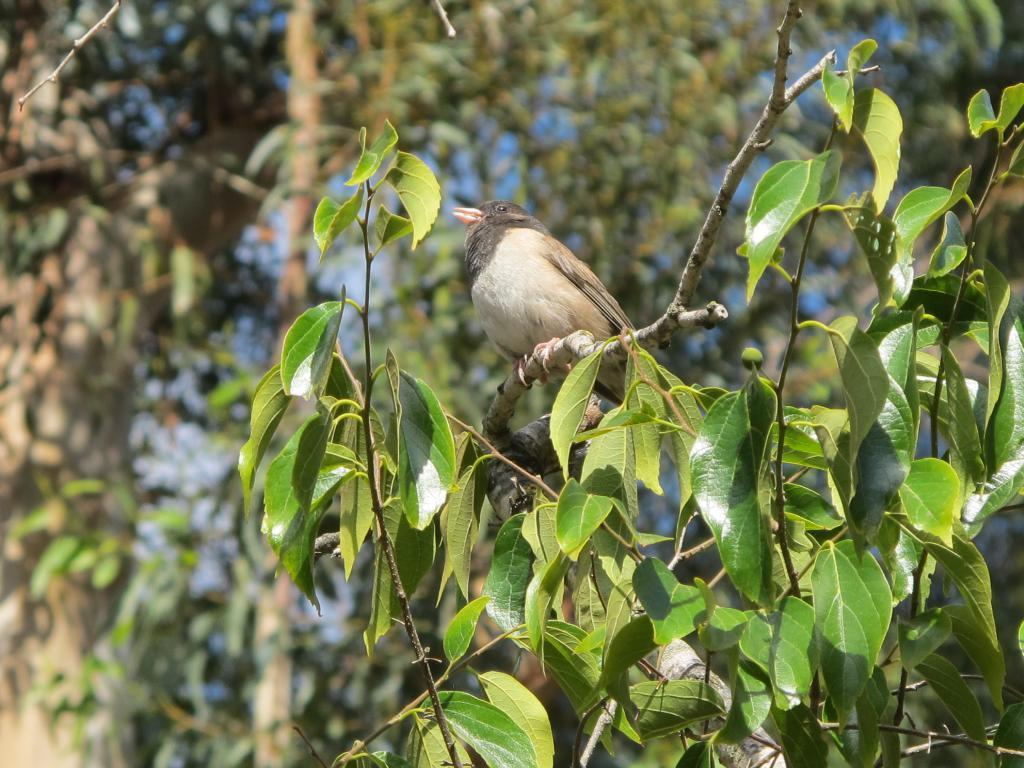What is on the tree stem in the image? There is a bird on the tree stem in the image. What color are the leaves on the trees? Green leaves are visible in the image. How would you describe the background of the image? The background has a blurred view. What type of vegetation is present in the image? Trees are present in the image. Where is the desk located in the image? There is no desk present in the image. What type of balloon can be seen floating in the background? There is no balloon present in the image. 